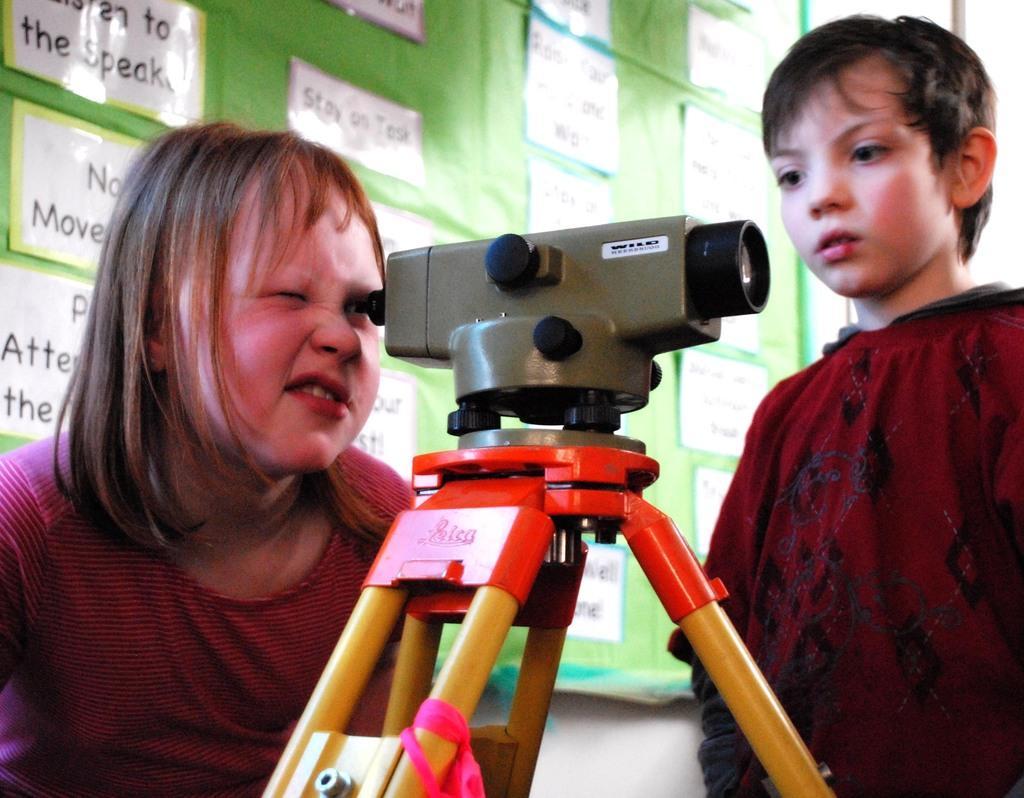Describe this image in one or two sentences. In this picture we can see a boy, girl, here we can see a camera, tripod and in the background we can see a wall, board, on this board we can see some posters on it. 